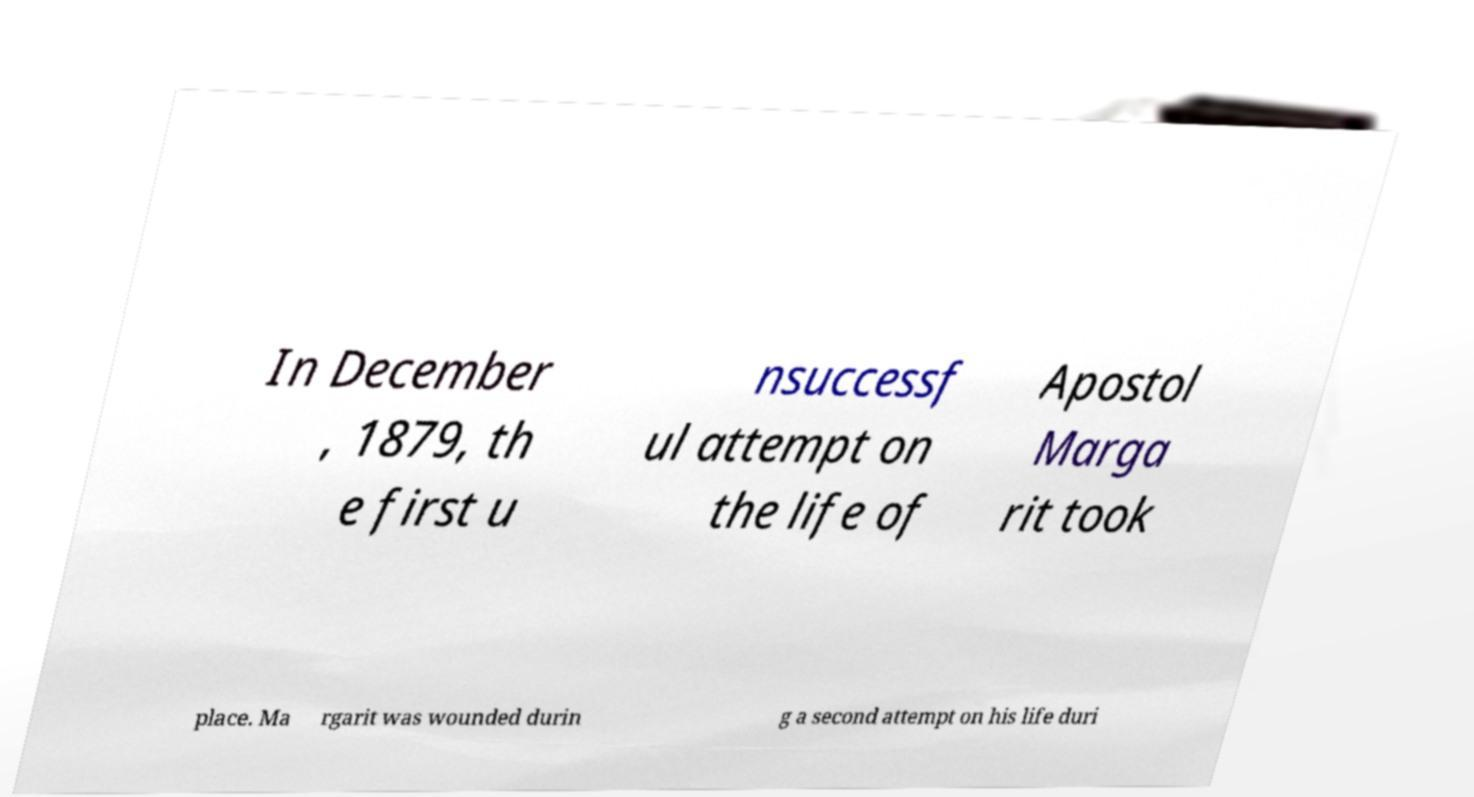Please identify and transcribe the text found in this image. In December , 1879, th e first u nsuccessf ul attempt on the life of Apostol Marga rit took place. Ma rgarit was wounded durin g a second attempt on his life duri 